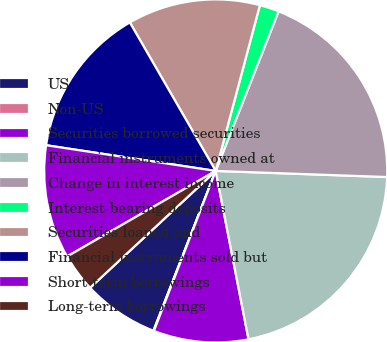<chart> <loc_0><loc_0><loc_500><loc_500><pie_chart><fcel>US<fcel>Non-US<fcel>Securities borrowed securities<fcel>Financial instruments owned at<fcel>Change in interest income<fcel>Interest-bearing deposits<fcel>Securities loaned and<fcel>Financial instruments sold but<fcel>Short-term borrowings<fcel>Long-term borrowings<nl><fcel>7.16%<fcel>0.05%<fcel>8.93%<fcel>21.37%<fcel>19.59%<fcel>1.83%<fcel>12.49%<fcel>14.26%<fcel>10.71%<fcel>3.61%<nl></chart> 